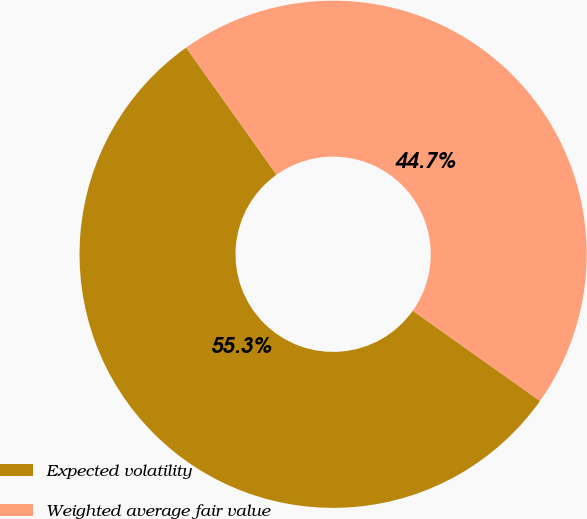Convert chart. <chart><loc_0><loc_0><loc_500><loc_500><pie_chart><fcel>Expected volatility<fcel>Weighted average fair value<nl><fcel>55.35%<fcel>44.65%<nl></chart> 